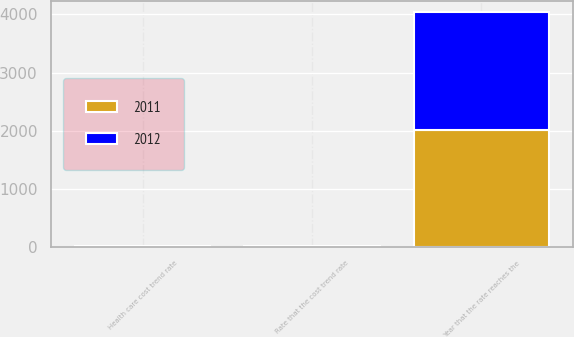Convert chart to OTSL. <chart><loc_0><loc_0><loc_500><loc_500><stacked_bar_chart><ecel><fcel>Health care cost trend rate<fcel>Rate that the cost trend rate<fcel>Year that the rate reaches the<nl><fcel>2012<fcel>7.5<fcel>5<fcel>2017<nl><fcel>2011<fcel>8<fcel>5<fcel>2017<nl></chart> 